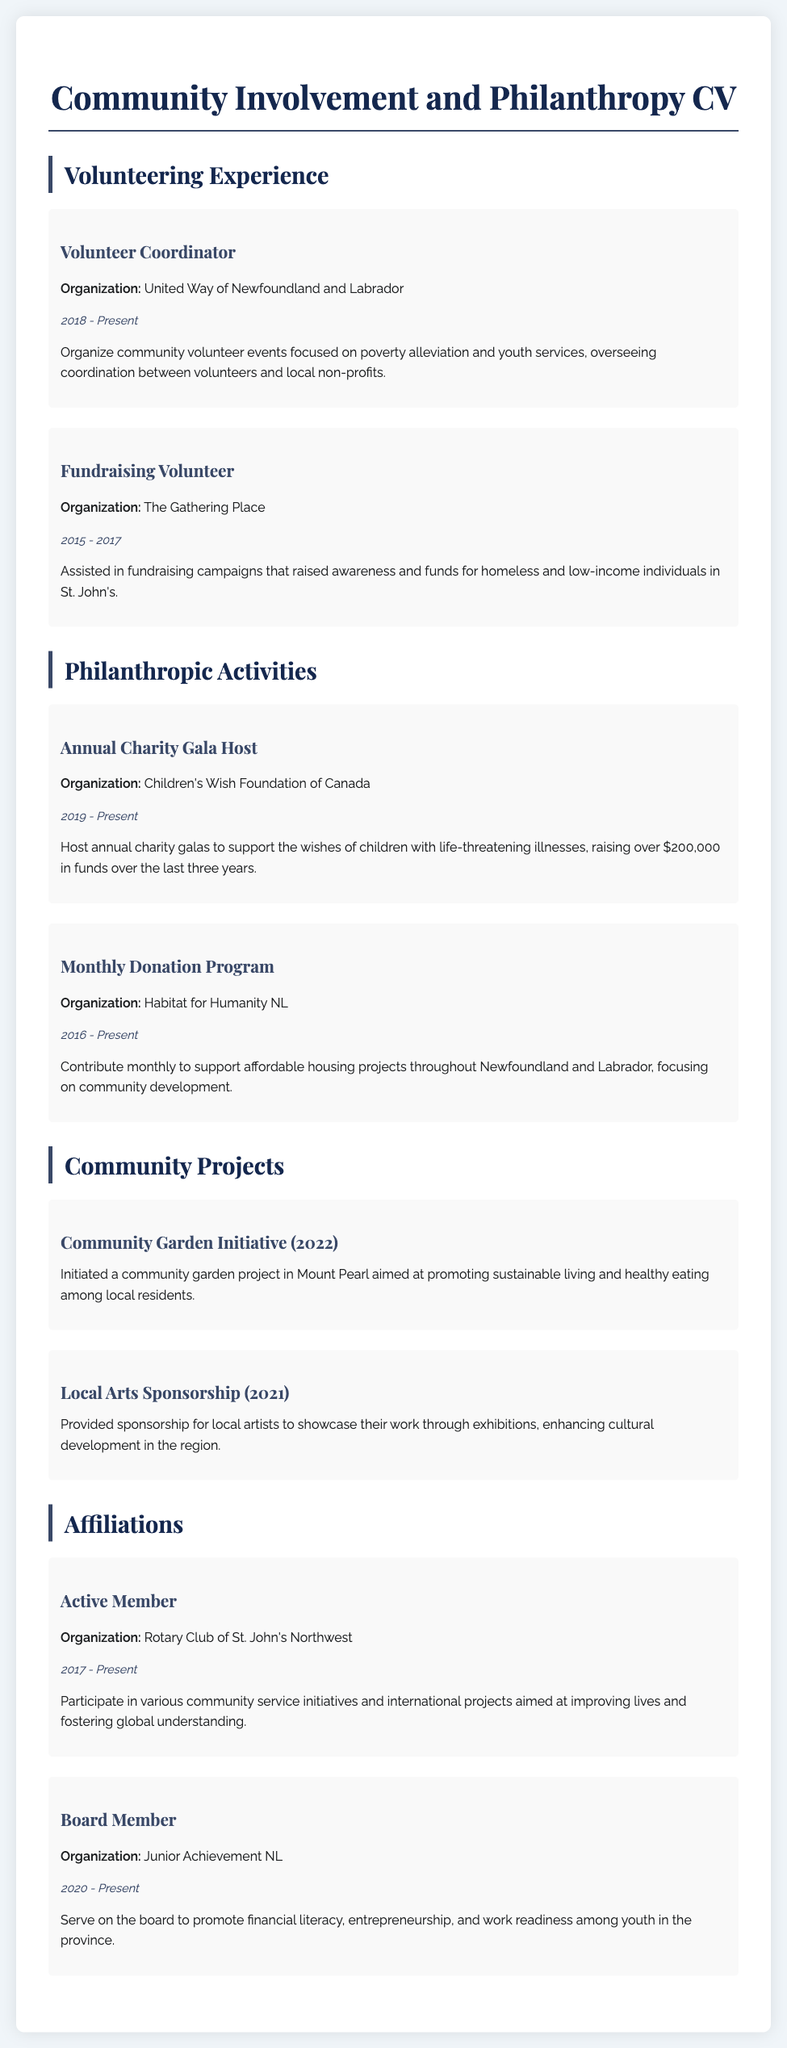what is the name of the organization where the Volunteer Coordinator works? The Volunteer Coordinator works with the United Way of Newfoundland and Labrador.
Answer: United Way of Newfoundland and Labrador in what year did the Monthly Donation Program start? The Monthly Donation Program started in 2016.
Answer: 2016 how much money has been raised through the Annual Charity Gala? The Annual Charity Gala has raised over $200,000 in funds.
Answer: $200,000 which community initiative was launched in 2022? The community initiative launched in 2022 is the Community Garden Initiative.
Answer: Community Garden Initiative what role does the individual hold in Junior Achievement NL? They serve on the board to promote various educational initiatives.
Answer: Board Member how long has the individual been involved with the Rotary Club of St. John's Northwest? They have been involved since 2017.
Answer: 2017 what is the focus of the contributions to Habitat for Humanity NL? The contributions focus on affordable housing projects throughout Newfoundland and Labrador.
Answer: Affordable housing projects which organization is associated with fundraising for homeless individuals? The organization associated with fundraising for homeless individuals is The Gathering Place.
Answer: The Gathering Place what is the primary purpose of the Local Arts Sponsorship? The primary purpose is to enhance cultural development in the region.
Answer: Enhance cultural development 